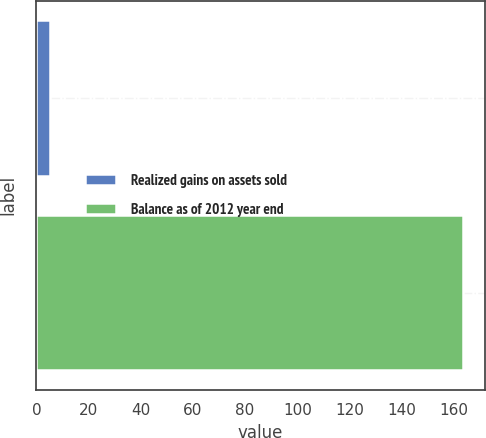<chart> <loc_0><loc_0><loc_500><loc_500><bar_chart><fcel>Realized gains on assets sold<fcel>Balance as of 2012 year end<nl><fcel>5.2<fcel>163.6<nl></chart> 